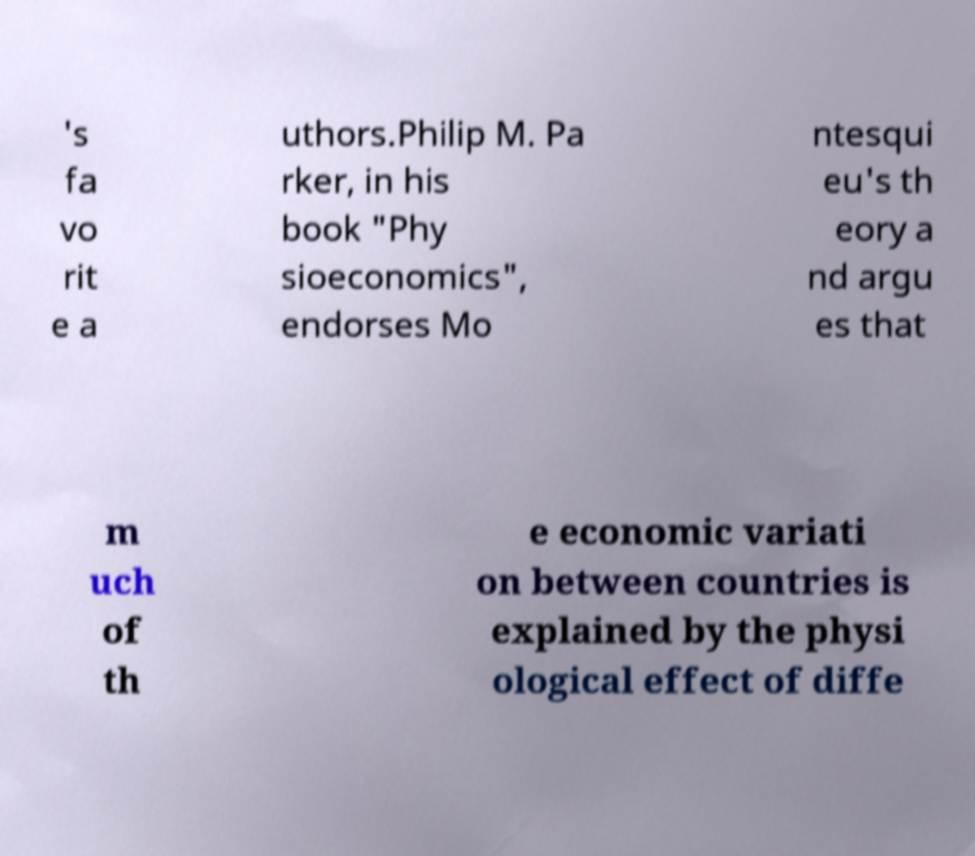There's text embedded in this image that I need extracted. Can you transcribe it verbatim? 's fa vo rit e a uthors.Philip M. Pa rker, in his book "Phy sioeconomics", endorses Mo ntesqui eu's th eory a nd argu es that m uch of th e economic variati on between countries is explained by the physi ological effect of diffe 